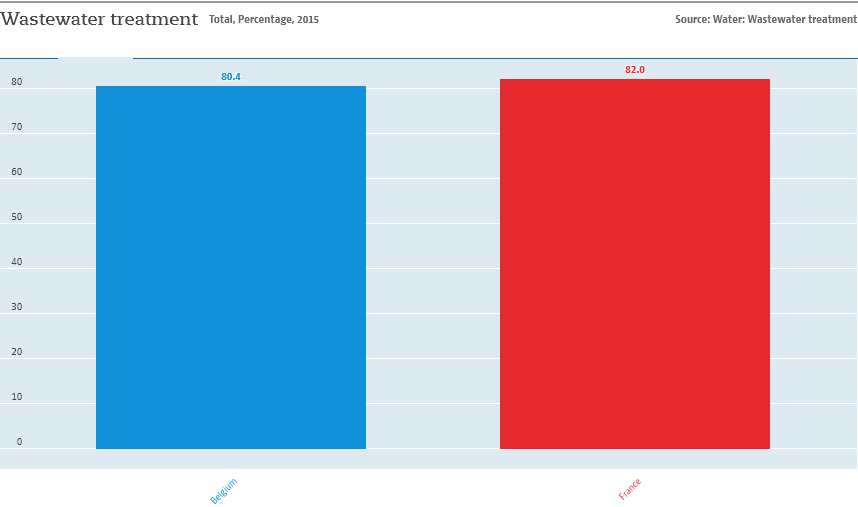List a handful of essential elements in this visual. The name of the rightmost bar is France. The average value of both the bars is 81.2. 